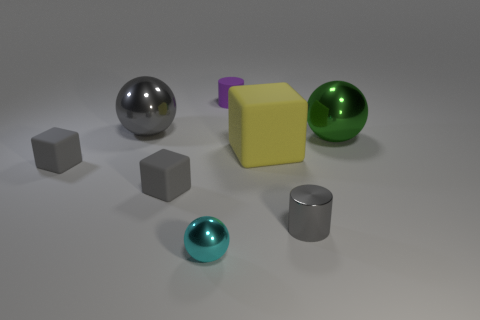Does the purple rubber object have the same shape as the big green shiny thing?
Your answer should be very brief. No. There is a tiny gray cylinder; are there any tiny metallic cylinders in front of it?
Provide a short and direct response. No. How many things are either yellow things or tiny cylinders?
Offer a terse response. 3. How many other things are the same size as the gray metal ball?
Provide a succinct answer. 2. What number of metallic objects are in front of the green sphere and behind the big green metal object?
Provide a short and direct response. 0. Does the shiny object on the right side of the metal cylinder have the same size as the cylinder that is on the left side of the tiny gray shiny cylinder?
Your answer should be very brief. No. What size is the gray metal object to the left of the tiny rubber cylinder?
Your answer should be very brief. Large. What number of objects are tiny metallic objects that are on the left side of the tiny gray metallic cylinder or tiny shiny things left of the purple thing?
Your response must be concise. 1. Is there any other thing that is the same color as the small ball?
Offer a terse response. No. Is the number of objects that are in front of the rubber cylinder the same as the number of small matte cylinders that are in front of the big yellow rubber block?
Provide a succinct answer. No. 